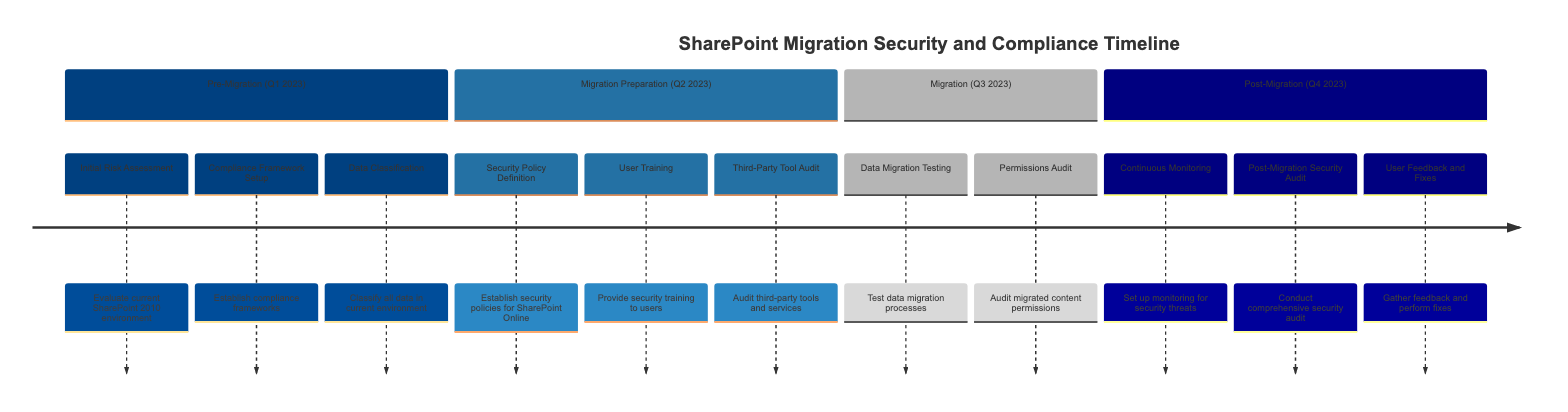what is the first task listed in the Pre-Migration phase? The diagram shows that the first task in the Pre-Migration phase is "Initial Risk Assessment." This can be found at the top of the list for that section.
Answer: Initial Risk Assessment how many tasks are in the Migration Preparation phase? By counting the tasks listed under the Migration Preparation section in the diagram, we see there are three tasks: Security Policy Definition, User Training, and Third-Party Tool Audit.
Answer: 3 what is the timeline for the Data Migration Testing task? Looking at the timeline for the task labeled "Data Migration Testing" in the Migration section, it is scheduled for Q3 2023.
Answer: Q3 2023 which phase includes the Continuous Monitoring task? The diagram shows that the task "Continuous Monitoring" is part of the Post-Migration phase, as it is listed under that section.
Answer: Post-Migration what is the last task in the Post-Migration phase? The final task listed in the Post-Migration phase is "User Feedback and Fixes," which appears last in the order of tasks for that phase.
Answer: User Feedback and Fixes does the Migration phase have an audit task? In reviewing the Migration phase, we find that there is indeed a task labeled "Permissions Audit," which confirms the presence of an audit task in that phase.
Answer: Yes which quarter is the Compliance Framework Setup scheduled for? The diagram indicates that "Compliance Framework Setup" is scheduled for Q1 2023 under the Pre-Migration phase, confirming the timing.
Answer: Q1 2023 is there a task related to user training in the diagram? Yes, the diagram includes a task labeled "User Training" in the Migration Preparation phase, which clearly addresses user training.
Answer: Yes 